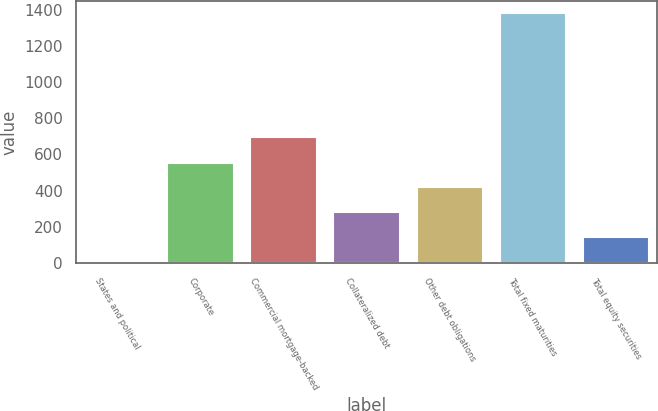Convert chart. <chart><loc_0><loc_0><loc_500><loc_500><bar_chart><fcel>States and political<fcel>Corporate<fcel>Commercial mortgage-backed<fcel>Collateralized debt<fcel>Other debt obligations<fcel>Total fixed maturities<fcel>Total equity securities<nl><fcel>4.9<fcel>555.5<fcel>695.8<fcel>280.2<fcel>417.85<fcel>1381.4<fcel>142.55<nl></chart> 